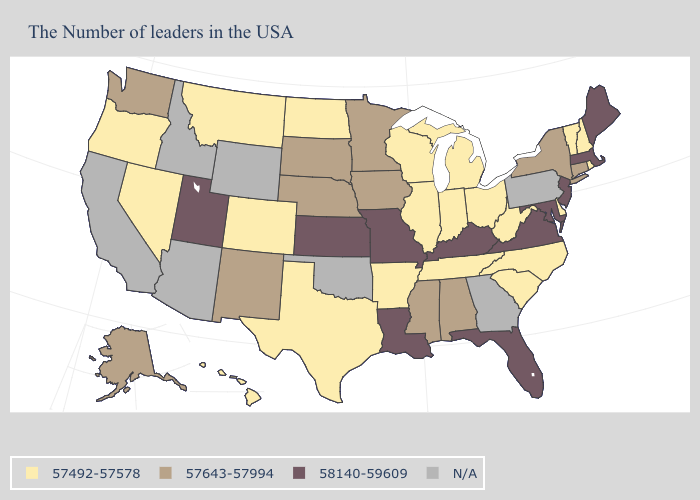Does the first symbol in the legend represent the smallest category?
Concise answer only. Yes. Among the states that border Massachusetts , does New Hampshire have the lowest value?
Quick response, please. Yes. Does Utah have the lowest value in the West?
Quick response, please. No. Among the states that border Maryland , which have the highest value?
Write a very short answer. Virginia. Among the states that border Oklahoma , which have the highest value?
Be succinct. Missouri, Kansas. Does Illinois have the lowest value in the USA?
Short answer required. Yes. What is the highest value in states that border New Mexico?
Answer briefly. 58140-59609. Name the states that have a value in the range 58140-59609?
Concise answer only. Maine, Massachusetts, New Jersey, Maryland, Virginia, Florida, Kentucky, Louisiana, Missouri, Kansas, Utah. Among the states that border Tennessee , does Virginia have the highest value?
Quick response, please. Yes. Among the states that border Washington , which have the highest value?
Quick response, please. Oregon. Name the states that have a value in the range 57643-57994?
Give a very brief answer. Connecticut, New York, Alabama, Mississippi, Minnesota, Iowa, Nebraska, South Dakota, New Mexico, Washington, Alaska. Does the map have missing data?
Quick response, please. Yes. Name the states that have a value in the range 58140-59609?
Write a very short answer. Maine, Massachusetts, New Jersey, Maryland, Virginia, Florida, Kentucky, Louisiana, Missouri, Kansas, Utah. Which states have the lowest value in the USA?
Concise answer only. Rhode Island, New Hampshire, Vermont, Delaware, North Carolina, South Carolina, West Virginia, Ohio, Michigan, Indiana, Tennessee, Wisconsin, Illinois, Arkansas, Texas, North Dakota, Colorado, Montana, Nevada, Oregon, Hawaii. 